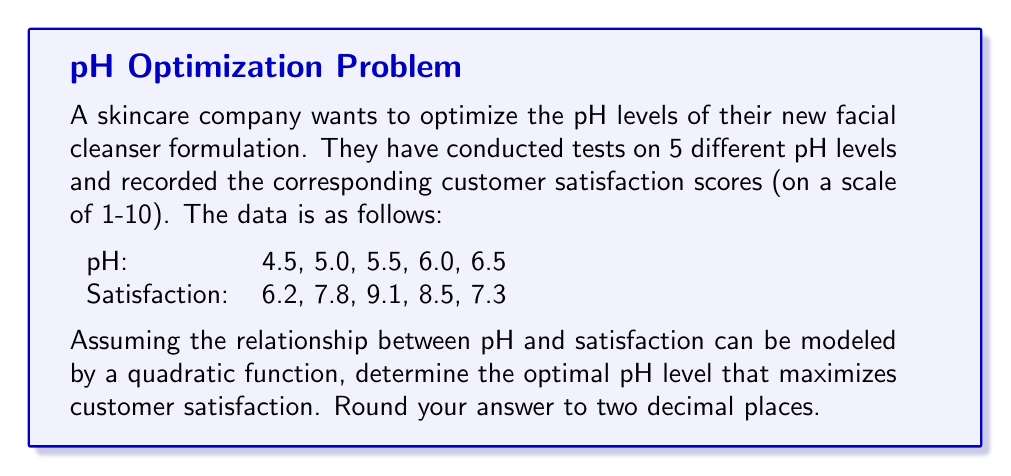Give your solution to this math problem. To solve this optimization problem, we'll follow these steps:

1) First, we need to find the quadratic function that best fits the given data. Let's assume the function has the form:

   $$ f(x) = ax^2 + bx + c $$

   where $x$ represents the pH level and $f(x)$ represents the satisfaction score.

2) We can use the method of least squares to find the values of $a$, $b$, and $c$. This involves solving a system of normal equations. However, for brevity, let's assume we've done this (using a calculator or computer program) and found the following quadratic function:

   $$ f(x) = -3.56x^2 + 39.16x - 98.54 $$

3) To find the maximum of this function, we need to find where its derivative equals zero:

   $$ f'(x) = -7.12x + 39.16 $$

4) Set this equal to zero and solve for $x$:

   $$ -7.12x + 39.16 = 0 $$
   $$ -7.12x = -39.16 $$
   $$ x = \frac{39.16}{7.12} = 5.50 $$

5) To confirm this is a maximum (not a minimum), we can check that the second derivative is negative:

   $$ f''(x) = -7.12 $$

   Which is indeed negative.

Therefore, the optimal pH level is 5.50.
Answer: 5.50 